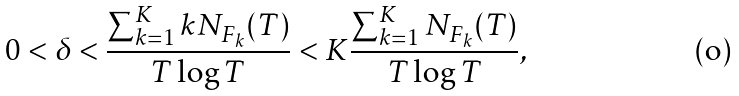<formula> <loc_0><loc_0><loc_500><loc_500>0 < \delta < \frac { \sum _ { k = 1 } ^ { K } k N _ { F _ { k } } ( T ) } { T \log T } < K \frac { \sum _ { k = 1 } ^ { K } N _ { F _ { k } } ( T ) } { T \log T } ,</formula> 